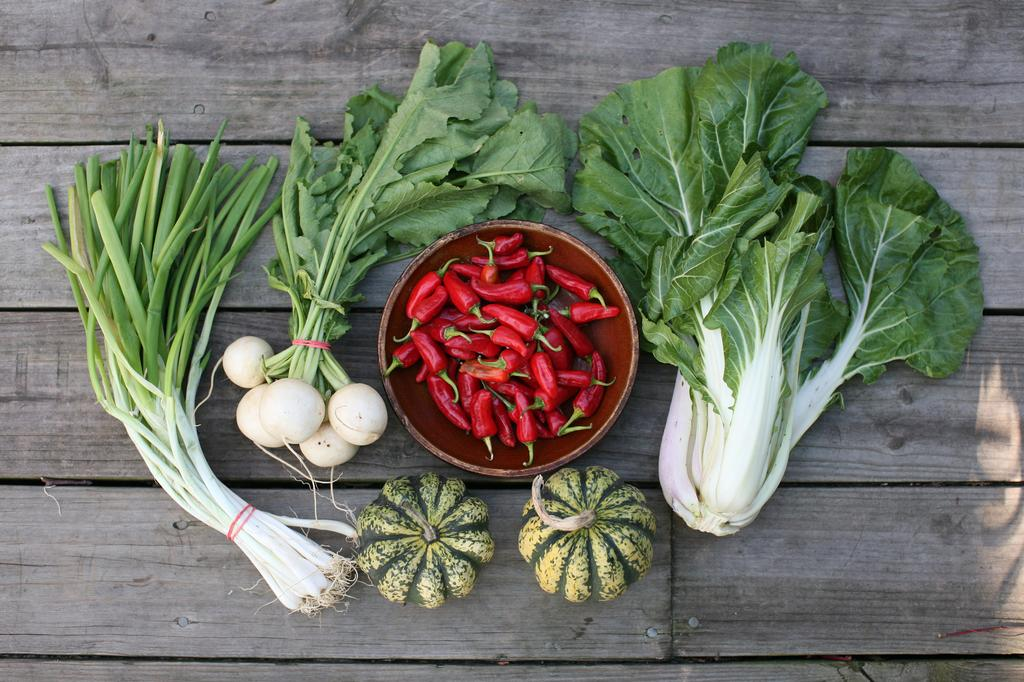What type of vegetables can be seen in the image? There are spring onions, cauliflower, and pumpkins in the image. Are there any other vegetables or ingredients in the image? Yes, there are red chilies in a bowl in the image. Who is the achiever in the image? There is no person present in the image, so it is not possible to identify an achiever. What request can be seen in the image? There is no request visible in the image; it features vegetables and a bowl of red chilies. 